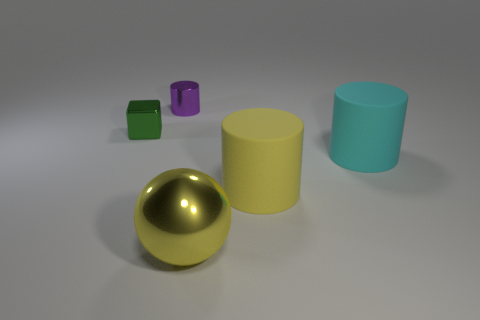There is a cylinder that is in front of the big cyan cylinder; is it the same color as the metallic ball?
Ensure brevity in your answer.  Yes. Is there anything else of the same color as the big ball?
Make the answer very short. Yes. The thing that is left of the large yellow rubber thing and in front of the cyan cylinder is what color?
Provide a succinct answer. Yellow. There is a yellow object that is to the right of the yellow sphere; what is its size?
Make the answer very short. Large. How many large things have the same material as the tiny block?
Your answer should be very brief. 1. There is a thing that is the same color as the big ball; what shape is it?
Keep it short and to the point. Cylinder. There is a big thing right of the yellow rubber thing; is it the same shape as the small green metallic object?
Make the answer very short. No. There is a tiny cylinder that is made of the same material as the yellow ball; what is its color?
Offer a terse response. Purple. Are there any green blocks behind the tiny metallic object that is in front of the cylinder behind the green metallic cube?
Give a very brief answer. No. The big yellow metal thing is what shape?
Give a very brief answer. Sphere. 